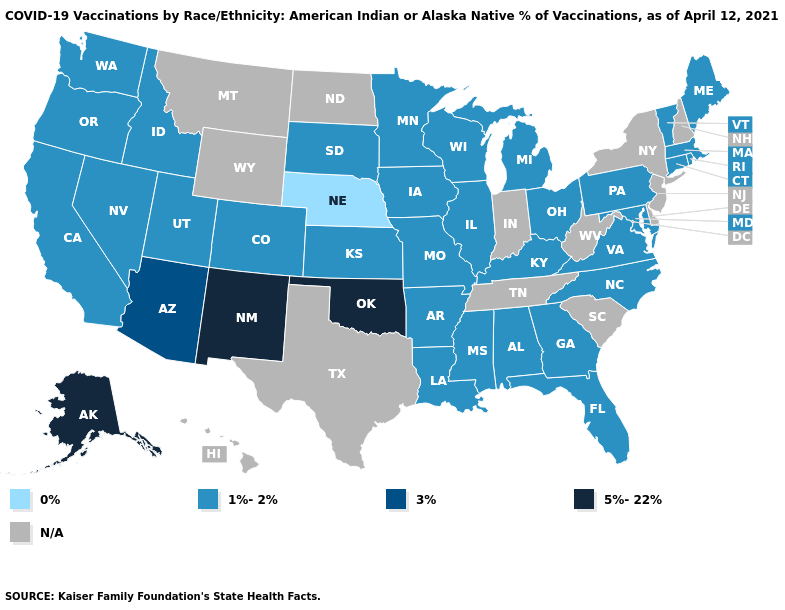Name the states that have a value in the range 1%-2%?
Give a very brief answer. Alabama, Arkansas, California, Colorado, Connecticut, Florida, Georgia, Idaho, Illinois, Iowa, Kansas, Kentucky, Louisiana, Maine, Maryland, Massachusetts, Michigan, Minnesota, Mississippi, Missouri, Nevada, North Carolina, Ohio, Oregon, Pennsylvania, Rhode Island, South Dakota, Utah, Vermont, Virginia, Washington, Wisconsin. What is the lowest value in states that border Wisconsin?
Concise answer only. 1%-2%. What is the value of West Virginia?
Short answer required. N/A. What is the value of Alaska?
Be succinct. 5%-22%. What is the value of Utah?
Give a very brief answer. 1%-2%. Name the states that have a value in the range 5%-22%?
Concise answer only. Alaska, New Mexico, Oklahoma. Does North Carolina have the lowest value in the South?
Be succinct. Yes. Name the states that have a value in the range 3%?
Write a very short answer. Arizona. Does the map have missing data?
Keep it brief. Yes. Name the states that have a value in the range 0%?
Keep it brief. Nebraska. Which states hav the highest value in the West?
Give a very brief answer. Alaska, New Mexico. Name the states that have a value in the range 3%?
Keep it brief. Arizona. Does the map have missing data?
Give a very brief answer. Yes. 